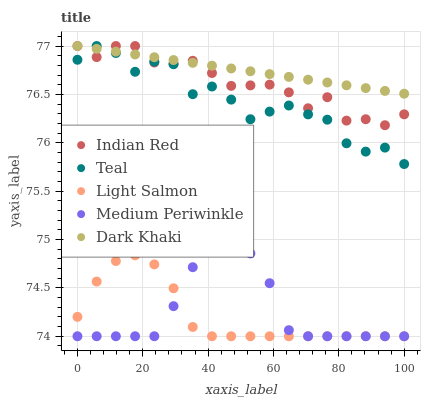Does Light Salmon have the minimum area under the curve?
Answer yes or no. Yes. Does Dark Khaki have the maximum area under the curve?
Answer yes or no. Yes. Does Medium Periwinkle have the minimum area under the curve?
Answer yes or no. No. Does Medium Periwinkle have the maximum area under the curve?
Answer yes or no. No. Is Dark Khaki the smoothest?
Answer yes or no. Yes. Is Teal the roughest?
Answer yes or no. Yes. Is Light Salmon the smoothest?
Answer yes or no. No. Is Light Salmon the roughest?
Answer yes or no. No. Does Light Salmon have the lowest value?
Answer yes or no. Yes. Does Teal have the lowest value?
Answer yes or no. No. Does Indian Red have the highest value?
Answer yes or no. Yes. Does Medium Periwinkle have the highest value?
Answer yes or no. No. Is Light Salmon less than Indian Red?
Answer yes or no. Yes. Is Indian Red greater than Light Salmon?
Answer yes or no. Yes. Does Medium Periwinkle intersect Light Salmon?
Answer yes or no. Yes. Is Medium Periwinkle less than Light Salmon?
Answer yes or no. No. Is Medium Periwinkle greater than Light Salmon?
Answer yes or no. No. Does Light Salmon intersect Indian Red?
Answer yes or no. No. 